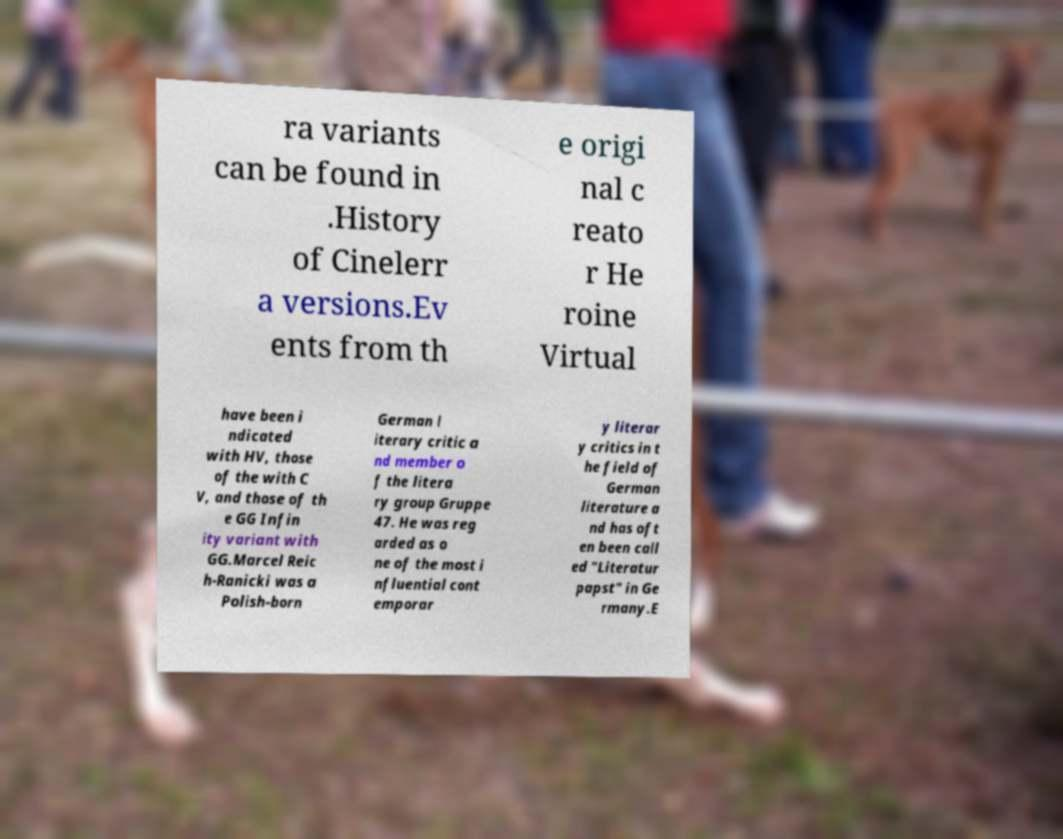Can you accurately transcribe the text from the provided image for me? ra variants can be found in .History of Cinelerr a versions.Ev ents from th e origi nal c reato r He roine Virtual have been i ndicated with HV, those of the with C V, and those of th e GG Infin ity variant with GG.Marcel Reic h-Ranicki was a Polish-born German l iterary critic a nd member o f the litera ry group Gruppe 47. He was reg arded as o ne of the most i nfluential cont emporar y literar y critics in t he field of German literature a nd has oft en been call ed "Literatur papst" in Ge rmany.E 